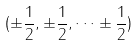Convert formula to latex. <formula><loc_0><loc_0><loc_500><loc_500>( \pm \frac { 1 } { 2 } , \pm \frac { 1 } { 2 } , \dots \pm \frac { 1 } { 2 } )</formula> 